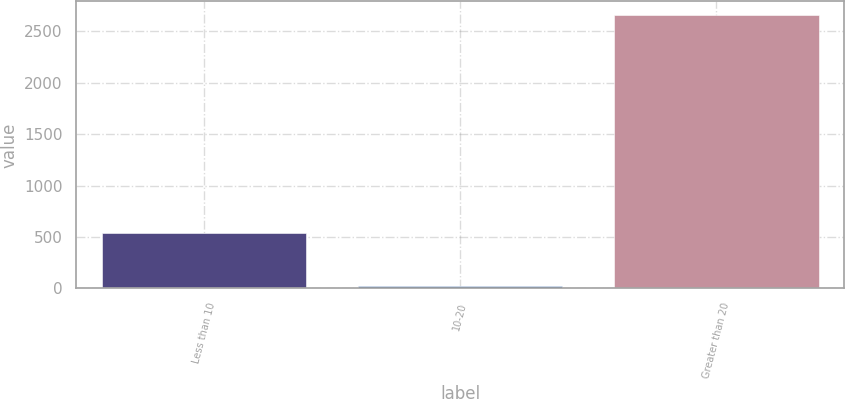<chart> <loc_0><loc_0><loc_500><loc_500><bar_chart><fcel>Less than 10<fcel>10-20<fcel>Greater than 20<nl><fcel>541.9<fcel>20<fcel>2659<nl></chart> 